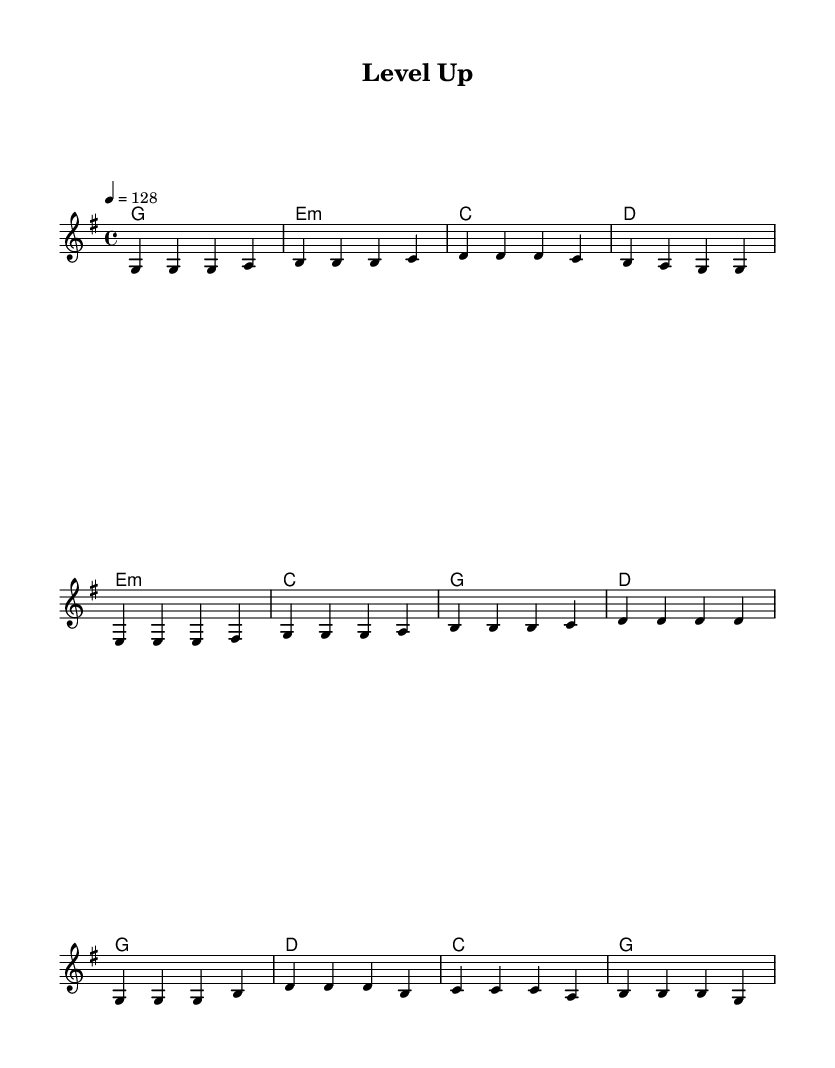What is the key signature of this music? The key signature indicates the notes that are sharp or flat throughout the piece. In this music, it is G major because it has one sharp (F#), which is indicated at the beginning of the staff.
Answer: G major What is the time signature of this music? The time signature is located at the beginning of the staff and shows how many beats are in each measure. In this music, it is 4/4, indicating four beats per measure with the quarter note receiving one beat.
Answer: 4/4 What is the tempo marking for this piece? The tempo marking is indicated in beats per minute (BPM) at the start of the piece. Here, it specifies 128 beats per minute, which means the music should be played at a relatively fast pace.
Answer: 128 How many sections are in the song? Analyzing the structure of the music, there are three distinct sections: a Verse, a Pre-Chorus, and a Chorus, each with different melodies and lyrics.
Answer: Three What lyrics are sung during the Chorus? The Lyrics for the Chorus are indicated clearly in the score, specifically under the corresponding melodic notes. They are "Level up, break through, No challenge can stop you, Level up, aim high, Reach for the digital sky."
Answer: Level up, break through, No challenge can stop you, Level up, aim high, Reach for the digital sky Which chord is used in the first measure of the verse? The first measure of the verse shows the chord symbol above the staff. In this case, it is G major, which typically accompanies the melody played.
Answer: G What is the main theme of the lyrics? The lyrics reflect a motivational theme about overcoming challenges and striving for success, emphasizing persistence and ambition. The overall message encourages pushing through obstacles.
Answer: Overcoming challenges 